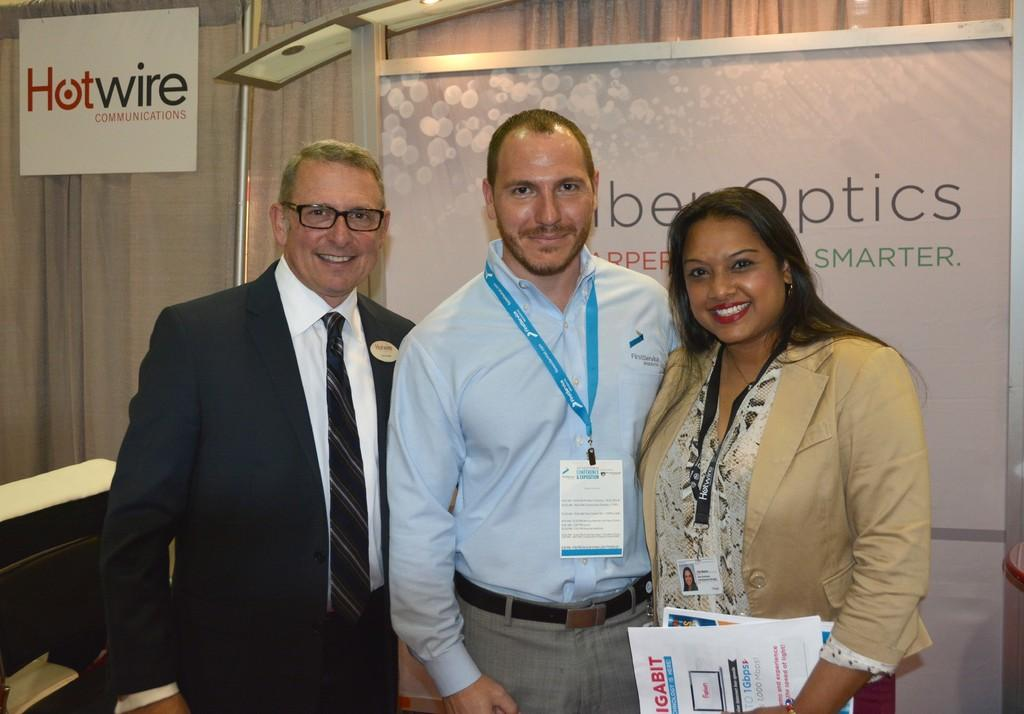How many individuals are present in the image? There are three people in the image. Can you describe the background of the image? There is a board with text in the background of the image. What type of cakes can be seen in the store in the image? There is no store or cakes present in the image; it features three people and a board with text in the background. 